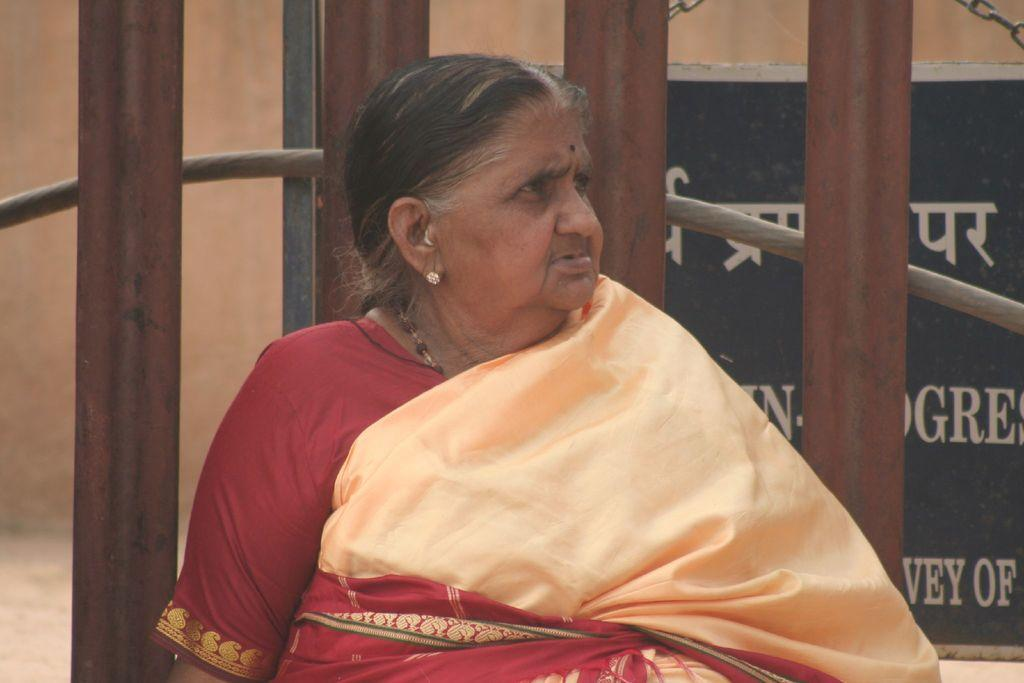Who is present in the image? There is a woman in the image. What is the woman doing in the image? The woman is standing in the image. What is the woman wearing in the image? The woman is wearing a sari in the image. What objects can be seen in the background of the image? There are iron rods visible in the image. How many examples of cattle can be seen in the image? There are no examples of cattle present in the image. What type of tent is visible in the image? There is no tent present in the image. 